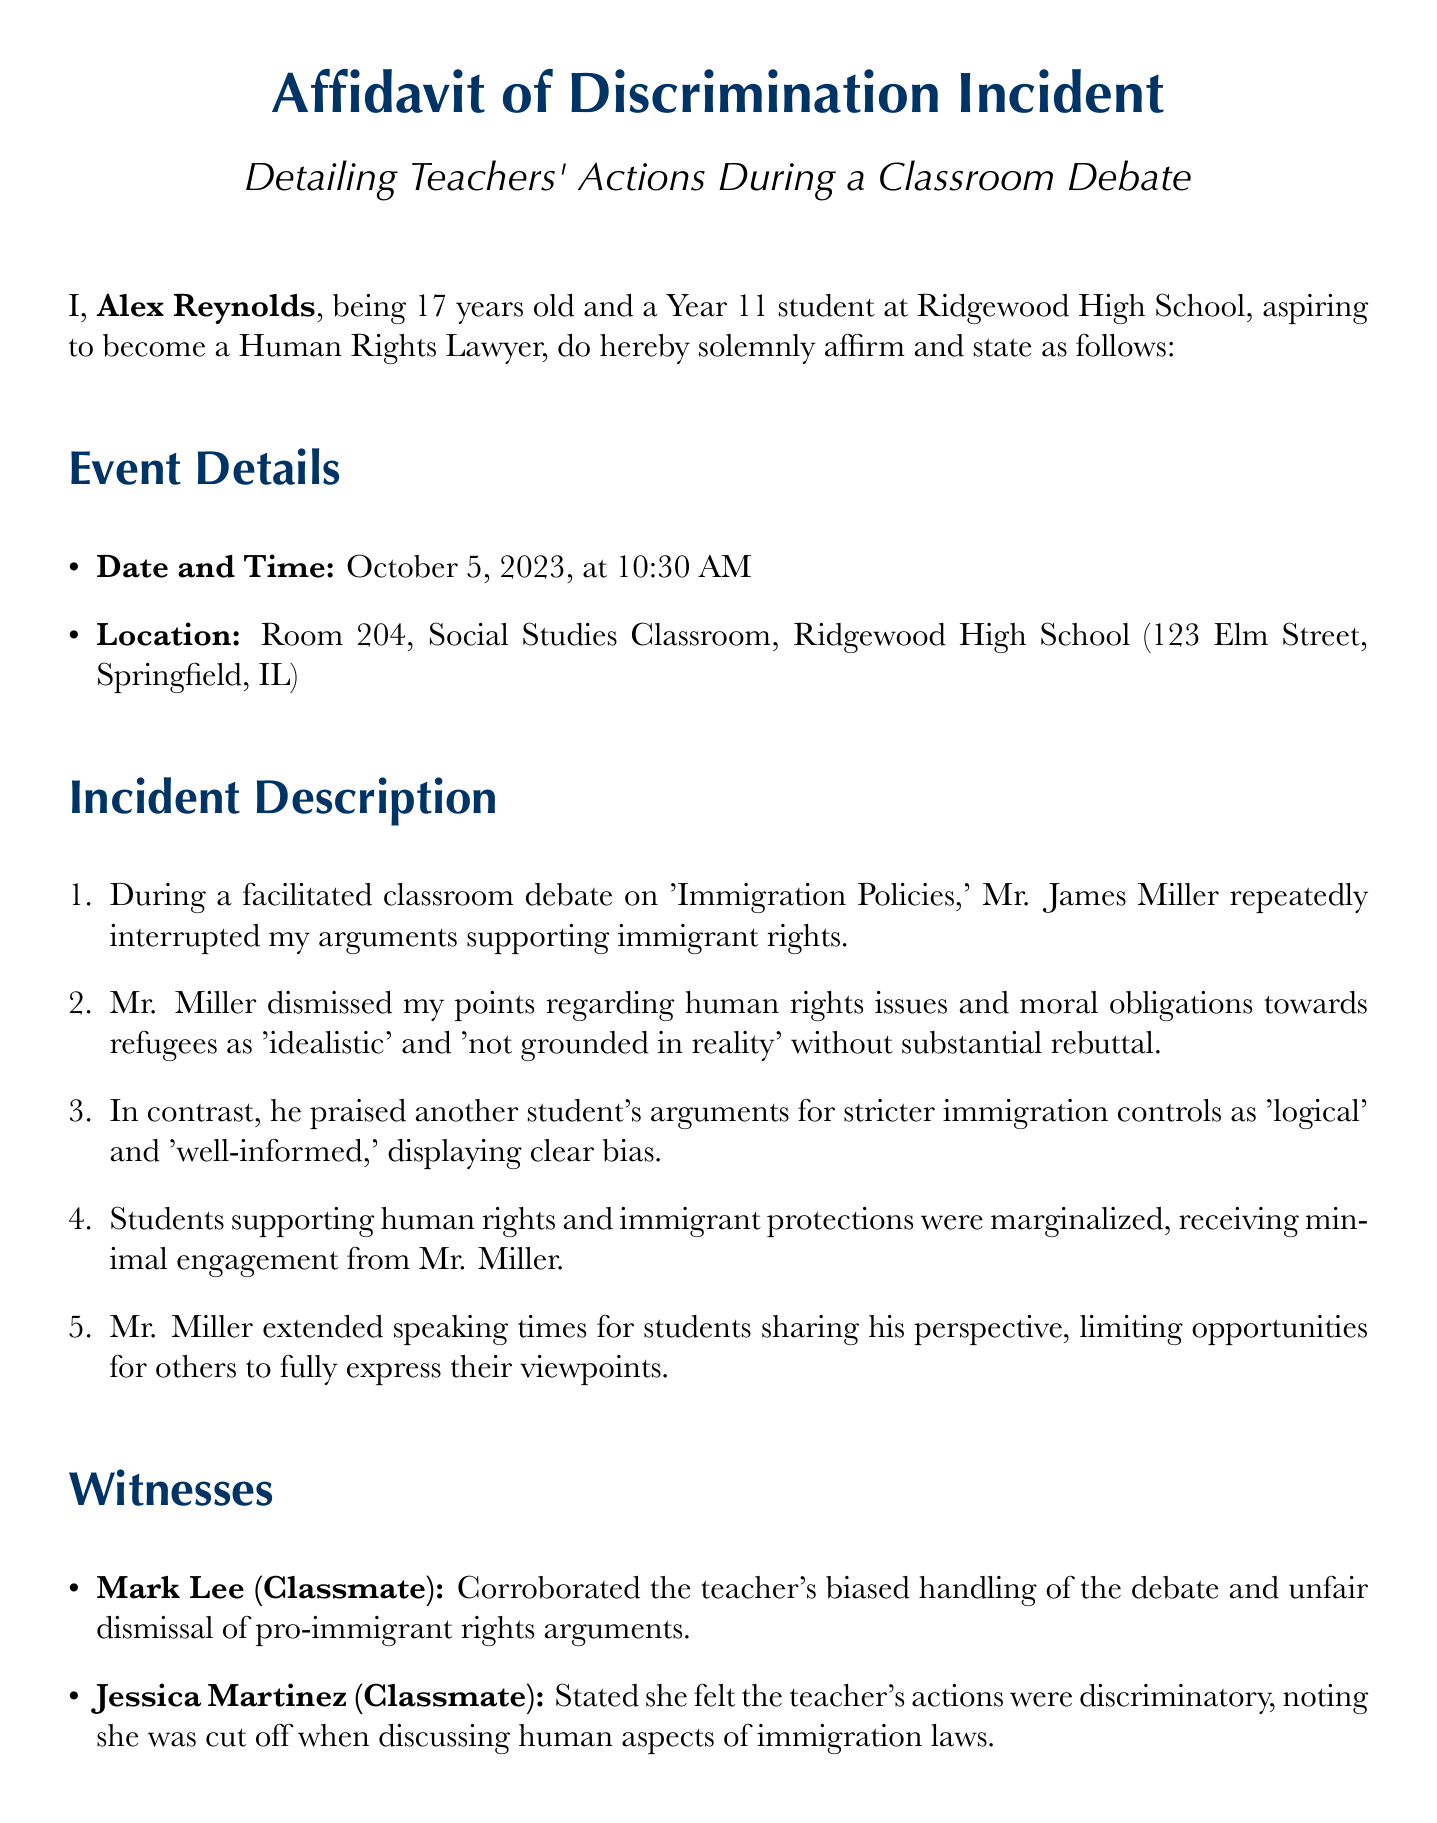what is the date of the incident? The date of the incident is clearly stated in the document as October 5, 2023.
Answer: October 5, 2023 who is the affiant? The affiant is the individual making the affidavit, which is stated as Alex Reynolds.
Answer: Alex Reynolds what is the location of the incident? The document specifies the location as Room 204, Social Studies Classroom, Ridgewood High School.
Answer: Room 204, Social Studies Classroom, Ridgewood High School how did Mr. Miller describe the arguments supporting immigrant rights? Mr. Miller described the arguments as 'idealistic' and 'not grounded in reality.'
Answer: 'idealistic' and 'not grounded in reality' who corroborated the teacher's biased handling of the debate? The document states that Mark Lee corroborated the teacher's biased handling of the debate.
Answer: Mark Lee what impact did the incident have on Alex Reynolds? The incident made Alex feel undervalued and disrespected, affecting confidence to participate.
Answer: undervalued and disrespected how did Mr. Miller treat students who shared his perspective during the debate? The document indicates that Mr. Miller extended speaking times for students sharing his perspective.
Answer: extended speaking times when was the affidavit signed? The affidavit was signed on October 10, 2023.
Answer: October 10, 2023 